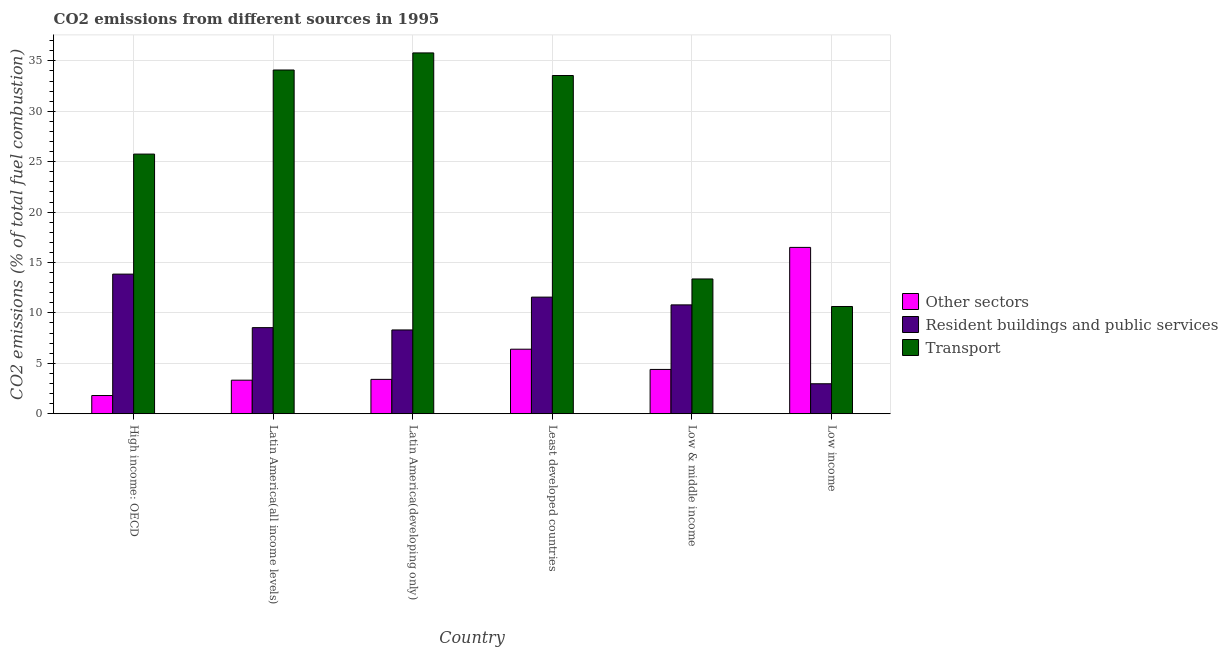What is the label of the 6th group of bars from the left?
Give a very brief answer. Low income. In how many cases, is the number of bars for a given country not equal to the number of legend labels?
Provide a short and direct response. 0. What is the percentage of co2 emissions from resident buildings and public services in High income: OECD?
Offer a terse response. 13.85. Across all countries, what is the maximum percentage of co2 emissions from resident buildings and public services?
Your response must be concise. 13.85. Across all countries, what is the minimum percentage of co2 emissions from transport?
Keep it short and to the point. 10.64. In which country was the percentage of co2 emissions from other sectors maximum?
Your response must be concise. Low income. In which country was the percentage of co2 emissions from resident buildings and public services minimum?
Ensure brevity in your answer.  Low income. What is the total percentage of co2 emissions from other sectors in the graph?
Your response must be concise. 35.84. What is the difference between the percentage of co2 emissions from transport in High income: OECD and that in Latin America(all income levels)?
Offer a very short reply. -8.34. What is the difference between the percentage of co2 emissions from transport in Low income and the percentage of co2 emissions from other sectors in Low & middle income?
Keep it short and to the point. 6.24. What is the average percentage of co2 emissions from other sectors per country?
Make the answer very short. 5.97. What is the difference between the percentage of co2 emissions from resident buildings and public services and percentage of co2 emissions from other sectors in Latin America(developing only)?
Make the answer very short. 4.9. In how many countries, is the percentage of co2 emissions from resident buildings and public services greater than 15 %?
Make the answer very short. 0. What is the ratio of the percentage of co2 emissions from transport in Latin America(all income levels) to that in Low & middle income?
Offer a very short reply. 2.55. What is the difference between the highest and the second highest percentage of co2 emissions from transport?
Make the answer very short. 1.69. What is the difference between the highest and the lowest percentage of co2 emissions from other sectors?
Provide a succinct answer. 14.69. Is the sum of the percentage of co2 emissions from transport in Latin America(developing only) and Low & middle income greater than the maximum percentage of co2 emissions from other sectors across all countries?
Your answer should be compact. Yes. What does the 1st bar from the left in Least developed countries represents?
Offer a terse response. Other sectors. What does the 3rd bar from the right in Latin America(all income levels) represents?
Your answer should be very brief. Other sectors. How many bars are there?
Keep it short and to the point. 18. Are all the bars in the graph horizontal?
Your answer should be very brief. No. What is the title of the graph?
Your answer should be very brief. CO2 emissions from different sources in 1995. Does "Consumption Tax" appear as one of the legend labels in the graph?
Your answer should be very brief. No. What is the label or title of the X-axis?
Keep it short and to the point. Country. What is the label or title of the Y-axis?
Offer a terse response. CO2 emissions (% of total fuel combustion). What is the CO2 emissions (% of total fuel combustion) of Other sectors in High income: OECD?
Your response must be concise. 1.81. What is the CO2 emissions (% of total fuel combustion) in Resident buildings and public services in High income: OECD?
Ensure brevity in your answer.  13.85. What is the CO2 emissions (% of total fuel combustion) of Transport in High income: OECD?
Give a very brief answer. 25.75. What is the CO2 emissions (% of total fuel combustion) in Other sectors in Latin America(all income levels)?
Provide a succinct answer. 3.33. What is the CO2 emissions (% of total fuel combustion) of Resident buildings and public services in Latin America(all income levels)?
Provide a short and direct response. 8.54. What is the CO2 emissions (% of total fuel combustion) in Transport in Latin America(all income levels)?
Make the answer very short. 34.09. What is the CO2 emissions (% of total fuel combustion) in Other sectors in Latin America(developing only)?
Give a very brief answer. 3.41. What is the CO2 emissions (% of total fuel combustion) of Resident buildings and public services in Latin America(developing only)?
Offer a very short reply. 8.31. What is the CO2 emissions (% of total fuel combustion) of Transport in Latin America(developing only)?
Provide a short and direct response. 35.79. What is the CO2 emissions (% of total fuel combustion) in Other sectors in Least developed countries?
Provide a short and direct response. 6.4. What is the CO2 emissions (% of total fuel combustion) in Resident buildings and public services in Least developed countries?
Provide a short and direct response. 11.57. What is the CO2 emissions (% of total fuel combustion) in Transport in Least developed countries?
Your response must be concise. 33.55. What is the CO2 emissions (% of total fuel combustion) in Other sectors in Low & middle income?
Give a very brief answer. 4.39. What is the CO2 emissions (% of total fuel combustion) in Resident buildings and public services in Low & middle income?
Give a very brief answer. 10.8. What is the CO2 emissions (% of total fuel combustion) of Transport in Low & middle income?
Make the answer very short. 13.37. What is the CO2 emissions (% of total fuel combustion) in Other sectors in Low income?
Your answer should be very brief. 16.5. What is the CO2 emissions (% of total fuel combustion) in Resident buildings and public services in Low income?
Keep it short and to the point. 2.97. What is the CO2 emissions (% of total fuel combustion) of Transport in Low income?
Offer a terse response. 10.64. Across all countries, what is the maximum CO2 emissions (% of total fuel combustion) in Other sectors?
Provide a short and direct response. 16.5. Across all countries, what is the maximum CO2 emissions (% of total fuel combustion) in Resident buildings and public services?
Make the answer very short. 13.85. Across all countries, what is the maximum CO2 emissions (% of total fuel combustion) in Transport?
Provide a succinct answer. 35.79. Across all countries, what is the minimum CO2 emissions (% of total fuel combustion) in Other sectors?
Offer a terse response. 1.81. Across all countries, what is the minimum CO2 emissions (% of total fuel combustion) of Resident buildings and public services?
Make the answer very short. 2.97. Across all countries, what is the minimum CO2 emissions (% of total fuel combustion) in Transport?
Provide a short and direct response. 10.64. What is the total CO2 emissions (% of total fuel combustion) of Other sectors in the graph?
Offer a very short reply. 35.84. What is the total CO2 emissions (% of total fuel combustion) of Resident buildings and public services in the graph?
Provide a short and direct response. 56.04. What is the total CO2 emissions (% of total fuel combustion) of Transport in the graph?
Give a very brief answer. 153.19. What is the difference between the CO2 emissions (% of total fuel combustion) in Other sectors in High income: OECD and that in Latin America(all income levels)?
Your answer should be very brief. -1.52. What is the difference between the CO2 emissions (% of total fuel combustion) of Resident buildings and public services in High income: OECD and that in Latin America(all income levels)?
Your answer should be compact. 5.31. What is the difference between the CO2 emissions (% of total fuel combustion) of Transport in High income: OECD and that in Latin America(all income levels)?
Provide a short and direct response. -8.34. What is the difference between the CO2 emissions (% of total fuel combustion) of Other sectors in High income: OECD and that in Latin America(developing only)?
Keep it short and to the point. -1.6. What is the difference between the CO2 emissions (% of total fuel combustion) in Resident buildings and public services in High income: OECD and that in Latin America(developing only)?
Offer a terse response. 5.54. What is the difference between the CO2 emissions (% of total fuel combustion) of Transport in High income: OECD and that in Latin America(developing only)?
Make the answer very short. -10.03. What is the difference between the CO2 emissions (% of total fuel combustion) in Other sectors in High income: OECD and that in Least developed countries?
Provide a short and direct response. -4.59. What is the difference between the CO2 emissions (% of total fuel combustion) in Resident buildings and public services in High income: OECD and that in Least developed countries?
Your answer should be very brief. 2.28. What is the difference between the CO2 emissions (% of total fuel combustion) of Transport in High income: OECD and that in Least developed countries?
Your response must be concise. -7.79. What is the difference between the CO2 emissions (% of total fuel combustion) of Other sectors in High income: OECD and that in Low & middle income?
Keep it short and to the point. -2.59. What is the difference between the CO2 emissions (% of total fuel combustion) in Resident buildings and public services in High income: OECD and that in Low & middle income?
Make the answer very short. 3.05. What is the difference between the CO2 emissions (% of total fuel combustion) of Transport in High income: OECD and that in Low & middle income?
Your answer should be very brief. 12.38. What is the difference between the CO2 emissions (% of total fuel combustion) in Other sectors in High income: OECD and that in Low income?
Make the answer very short. -14.69. What is the difference between the CO2 emissions (% of total fuel combustion) of Resident buildings and public services in High income: OECD and that in Low income?
Offer a very short reply. 10.87. What is the difference between the CO2 emissions (% of total fuel combustion) of Transport in High income: OECD and that in Low income?
Ensure brevity in your answer.  15.12. What is the difference between the CO2 emissions (% of total fuel combustion) of Other sectors in Latin America(all income levels) and that in Latin America(developing only)?
Your response must be concise. -0.08. What is the difference between the CO2 emissions (% of total fuel combustion) in Resident buildings and public services in Latin America(all income levels) and that in Latin America(developing only)?
Give a very brief answer. 0.23. What is the difference between the CO2 emissions (% of total fuel combustion) of Transport in Latin America(all income levels) and that in Latin America(developing only)?
Give a very brief answer. -1.69. What is the difference between the CO2 emissions (% of total fuel combustion) of Other sectors in Latin America(all income levels) and that in Least developed countries?
Make the answer very short. -3.07. What is the difference between the CO2 emissions (% of total fuel combustion) in Resident buildings and public services in Latin America(all income levels) and that in Least developed countries?
Make the answer very short. -3.03. What is the difference between the CO2 emissions (% of total fuel combustion) of Transport in Latin America(all income levels) and that in Least developed countries?
Offer a terse response. 0.55. What is the difference between the CO2 emissions (% of total fuel combustion) of Other sectors in Latin America(all income levels) and that in Low & middle income?
Provide a short and direct response. -1.07. What is the difference between the CO2 emissions (% of total fuel combustion) in Resident buildings and public services in Latin America(all income levels) and that in Low & middle income?
Offer a terse response. -2.26. What is the difference between the CO2 emissions (% of total fuel combustion) in Transport in Latin America(all income levels) and that in Low & middle income?
Your answer should be very brief. 20.72. What is the difference between the CO2 emissions (% of total fuel combustion) of Other sectors in Latin America(all income levels) and that in Low income?
Make the answer very short. -13.17. What is the difference between the CO2 emissions (% of total fuel combustion) in Resident buildings and public services in Latin America(all income levels) and that in Low income?
Your response must be concise. 5.57. What is the difference between the CO2 emissions (% of total fuel combustion) in Transport in Latin America(all income levels) and that in Low income?
Give a very brief answer. 23.46. What is the difference between the CO2 emissions (% of total fuel combustion) of Other sectors in Latin America(developing only) and that in Least developed countries?
Give a very brief answer. -2.99. What is the difference between the CO2 emissions (% of total fuel combustion) of Resident buildings and public services in Latin America(developing only) and that in Least developed countries?
Ensure brevity in your answer.  -3.26. What is the difference between the CO2 emissions (% of total fuel combustion) of Transport in Latin America(developing only) and that in Least developed countries?
Offer a very short reply. 2.24. What is the difference between the CO2 emissions (% of total fuel combustion) in Other sectors in Latin America(developing only) and that in Low & middle income?
Provide a short and direct response. -0.99. What is the difference between the CO2 emissions (% of total fuel combustion) of Resident buildings and public services in Latin America(developing only) and that in Low & middle income?
Your answer should be compact. -2.49. What is the difference between the CO2 emissions (% of total fuel combustion) in Transport in Latin America(developing only) and that in Low & middle income?
Your answer should be compact. 22.42. What is the difference between the CO2 emissions (% of total fuel combustion) in Other sectors in Latin America(developing only) and that in Low income?
Provide a short and direct response. -13.09. What is the difference between the CO2 emissions (% of total fuel combustion) of Resident buildings and public services in Latin America(developing only) and that in Low income?
Offer a terse response. 5.34. What is the difference between the CO2 emissions (% of total fuel combustion) of Transport in Latin America(developing only) and that in Low income?
Your answer should be compact. 25.15. What is the difference between the CO2 emissions (% of total fuel combustion) of Other sectors in Least developed countries and that in Low & middle income?
Give a very brief answer. 2.01. What is the difference between the CO2 emissions (% of total fuel combustion) in Resident buildings and public services in Least developed countries and that in Low & middle income?
Offer a very short reply. 0.77. What is the difference between the CO2 emissions (% of total fuel combustion) in Transport in Least developed countries and that in Low & middle income?
Give a very brief answer. 20.18. What is the difference between the CO2 emissions (% of total fuel combustion) of Other sectors in Least developed countries and that in Low income?
Keep it short and to the point. -10.1. What is the difference between the CO2 emissions (% of total fuel combustion) of Resident buildings and public services in Least developed countries and that in Low income?
Your answer should be very brief. 8.59. What is the difference between the CO2 emissions (% of total fuel combustion) in Transport in Least developed countries and that in Low income?
Ensure brevity in your answer.  22.91. What is the difference between the CO2 emissions (% of total fuel combustion) in Other sectors in Low & middle income and that in Low income?
Ensure brevity in your answer.  -12.1. What is the difference between the CO2 emissions (% of total fuel combustion) of Resident buildings and public services in Low & middle income and that in Low income?
Provide a short and direct response. 7.82. What is the difference between the CO2 emissions (% of total fuel combustion) in Transport in Low & middle income and that in Low income?
Ensure brevity in your answer.  2.73. What is the difference between the CO2 emissions (% of total fuel combustion) in Other sectors in High income: OECD and the CO2 emissions (% of total fuel combustion) in Resident buildings and public services in Latin America(all income levels)?
Offer a very short reply. -6.73. What is the difference between the CO2 emissions (% of total fuel combustion) in Other sectors in High income: OECD and the CO2 emissions (% of total fuel combustion) in Transport in Latin America(all income levels)?
Ensure brevity in your answer.  -32.29. What is the difference between the CO2 emissions (% of total fuel combustion) in Resident buildings and public services in High income: OECD and the CO2 emissions (% of total fuel combustion) in Transport in Latin America(all income levels)?
Offer a very short reply. -20.25. What is the difference between the CO2 emissions (% of total fuel combustion) in Other sectors in High income: OECD and the CO2 emissions (% of total fuel combustion) in Resident buildings and public services in Latin America(developing only)?
Ensure brevity in your answer.  -6.5. What is the difference between the CO2 emissions (% of total fuel combustion) in Other sectors in High income: OECD and the CO2 emissions (% of total fuel combustion) in Transport in Latin America(developing only)?
Your response must be concise. -33.98. What is the difference between the CO2 emissions (% of total fuel combustion) in Resident buildings and public services in High income: OECD and the CO2 emissions (% of total fuel combustion) in Transport in Latin America(developing only)?
Offer a very short reply. -21.94. What is the difference between the CO2 emissions (% of total fuel combustion) in Other sectors in High income: OECD and the CO2 emissions (% of total fuel combustion) in Resident buildings and public services in Least developed countries?
Provide a short and direct response. -9.76. What is the difference between the CO2 emissions (% of total fuel combustion) of Other sectors in High income: OECD and the CO2 emissions (% of total fuel combustion) of Transport in Least developed countries?
Give a very brief answer. -31.74. What is the difference between the CO2 emissions (% of total fuel combustion) in Resident buildings and public services in High income: OECD and the CO2 emissions (% of total fuel combustion) in Transport in Least developed countries?
Keep it short and to the point. -19.7. What is the difference between the CO2 emissions (% of total fuel combustion) in Other sectors in High income: OECD and the CO2 emissions (% of total fuel combustion) in Resident buildings and public services in Low & middle income?
Offer a very short reply. -8.99. What is the difference between the CO2 emissions (% of total fuel combustion) of Other sectors in High income: OECD and the CO2 emissions (% of total fuel combustion) of Transport in Low & middle income?
Offer a terse response. -11.56. What is the difference between the CO2 emissions (% of total fuel combustion) of Resident buildings and public services in High income: OECD and the CO2 emissions (% of total fuel combustion) of Transport in Low & middle income?
Make the answer very short. 0.48. What is the difference between the CO2 emissions (% of total fuel combustion) of Other sectors in High income: OECD and the CO2 emissions (% of total fuel combustion) of Resident buildings and public services in Low income?
Your answer should be very brief. -1.17. What is the difference between the CO2 emissions (% of total fuel combustion) of Other sectors in High income: OECD and the CO2 emissions (% of total fuel combustion) of Transport in Low income?
Make the answer very short. -8.83. What is the difference between the CO2 emissions (% of total fuel combustion) in Resident buildings and public services in High income: OECD and the CO2 emissions (% of total fuel combustion) in Transport in Low income?
Make the answer very short. 3.21. What is the difference between the CO2 emissions (% of total fuel combustion) in Other sectors in Latin America(all income levels) and the CO2 emissions (% of total fuel combustion) in Resident buildings and public services in Latin America(developing only)?
Provide a succinct answer. -4.98. What is the difference between the CO2 emissions (% of total fuel combustion) in Other sectors in Latin America(all income levels) and the CO2 emissions (% of total fuel combustion) in Transport in Latin America(developing only)?
Offer a terse response. -32.46. What is the difference between the CO2 emissions (% of total fuel combustion) in Resident buildings and public services in Latin America(all income levels) and the CO2 emissions (% of total fuel combustion) in Transport in Latin America(developing only)?
Keep it short and to the point. -27.25. What is the difference between the CO2 emissions (% of total fuel combustion) in Other sectors in Latin America(all income levels) and the CO2 emissions (% of total fuel combustion) in Resident buildings and public services in Least developed countries?
Provide a succinct answer. -8.24. What is the difference between the CO2 emissions (% of total fuel combustion) of Other sectors in Latin America(all income levels) and the CO2 emissions (% of total fuel combustion) of Transport in Least developed countries?
Provide a short and direct response. -30.22. What is the difference between the CO2 emissions (% of total fuel combustion) in Resident buildings and public services in Latin America(all income levels) and the CO2 emissions (% of total fuel combustion) in Transport in Least developed countries?
Offer a terse response. -25.01. What is the difference between the CO2 emissions (% of total fuel combustion) in Other sectors in Latin America(all income levels) and the CO2 emissions (% of total fuel combustion) in Resident buildings and public services in Low & middle income?
Provide a short and direct response. -7.47. What is the difference between the CO2 emissions (% of total fuel combustion) of Other sectors in Latin America(all income levels) and the CO2 emissions (% of total fuel combustion) of Transport in Low & middle income?
Your answer should be very brief. -10.04. What is the difference between the CO2 emissions (% of total fuel combustion) in Resident buildings and public services in Latin America(all income levels) and the CO2 emissions (% of total fuel combustion) in Transport in Low & middle income?
Offer a terse response. -4.83. What is the difference between the CO2 emissions (% of total fuel combustion) in Other sectors in Latin America(all income levels) and the CO2 emissions (% of total fuel combustion) in Resident buildings and public services in Low income?
Keep it short and to the point. 0.35. What is the difference between the CO2 emissions (% of total fuel combustion) of Other sectors in Latin America(all income levels) and the CO2 emissions (% of total fuel combustion) of Transport in Low income?
Make the answer very short. -7.31. What is the difference between the CO2 emissions (% of total fuel combustion) of Resident buildings and public services in Latin America(all income levels) and the CO2 emissions (% of total fuel combustion) of Transport in Low income?
Your answer should be very brief. -2.1. What is the difference between the CO2 emissions (% of total fuel combustion) of Other sectors in Latin America(developing only) and the CO2 emissions (% of total fuel combustion) of Resident buildings and public services in Least developed countries?
Offer a terse response. -8.16. What is the difference between the CO2 emissions (% of total fuel combustion) in Other sectors in Latin America(developing only) and the CO2 emissions (% of total fuel combustion) in Transport in Least developed countries?
Keep it short and to the point. -30.14. What is the difference between the CO2 emissions (% of total fuel combustion) of Resident buildings and public services in Latin America(developing only) and the CO2 emissions (% of total fuel combustion) of Transport in Least developed countries?
Give a very brief answer. -25.24. What is the difference between the CO2 emissions (% of total fuel combustion) in Other sectors in Latin America(developing only) and the CO2 emissions (% of total fuel combustion) in Resident buildings and public services in Low & middle income?
Ensure brevity in your answer.  -7.39. What is the difference between the CO2 emissions (% of total fuel combustion) in Other sectors in Latin America(developing only) and the CO2 emissions (% of total fuel combustion) in Transport in Low & middle income?
Your answer should be very brief. -9.96. What is the difference between the CO2 emissions (% of total fuel combustion) in Resident buildings and public services in Latin America(developing only) and the CO2 emissions (% of total fuel combustion) in Transport in Low & middle income?
Offer a terse response. -5.06. What is the difference between the CO2 emissions (% of total fuel combustion) in Other sectors in Latin America(developing only) and the CO2 emissions (% of total fuel combustion) in Resident buildings and public services in Low income?
Provide a succinct answer. 0.44. What is the difference between the CO2 emissions (% of total fuel combustion) of Other sectors in Latin America(developing only) and the CO2 emissions (% of total fuel combustion) of Transport in Low income?
Ensure brevity in your answer.  -7.23. What is the difference between the CO2 emissions (% of total fuel combustion) in Resident buildings and public services in Latin America(developing only) and the CO2 emissions (% of total fuel combustion) in Transport in Low income?
Offer a terse response. -2.33. What is the difference between the CO2 emissions (% of total fuel combustion) of Other sectors in Least developed countries and the CO2 emissions (% of total fuel combustion) of Resident buildings and public services in Low & middle income?
Make the answer very short. -4.4. What is the difference between the CO2 emissions (% of total fuel combustion) of Other sectors in Least developed countries and the CO2 emissions (% of total fuel combustion) of Transport in Low & middle income?
Ensure brevity in your answer.  -6.97. What is the difference between the CO2 emissions (% of total fuel combustion) of Resident buildings and public services in Least developed countries and the CO2 emissions (% of total fuel combustion) of Transport in Low & middle income?
Offer a terse response. -1.8. What is the difference between the CO2 emissions (% of total fuel combustion) of Other sectors in Least developed countries and the CO2 emissions (% of total fuel combustion) of Resident buildings and public services in Low income?
Make the answer very short. 3.43. What is the difference between the CO2 emissions (% of total fuel combustion) in Other sectors in Least developed countries and the CO2 emissions (% of total fuel combustion) in Transport in Low income?
Keep it short and to the point. -4.24. What is the difference between the CO2 emissions (% of total fuel combustion) in Resident buildings and public services in Least developed countries and the CO2 emissions (% of total fuel combustion) in Transport in Low income?
Ensure brevity in your answer.  0.93. What is the difference between the CO2 emissions (% of total fuel combustion) of Other sectors in Low & middle income and the CO2 emissions (% of total fuel combustion) of Resident buildings and public services in Low income?
Your answer should be compact. 1.42. What is the difference between the CO2 emissions (% of total fuel combustion) of Other sectors in Low & middle income and the CO2 emissions (% of total fuel combustion) of Transport in Low income?
Offer a very short reply. -6.24. What is the difference between the CO2 emissions (% of total fuel combustion) in Resident buildings and public services in Low & middle income and the CO2 emissions (% of total fuel combustion) in Transport in Low income?
Provide a short and direct response. 0.16. What is the average CO2 emissions (% of total fuel combustion) of Other sectors per country?
Provide a short and direct response. 5.97. What is the average CO2 emissions (% of total fuel combustion) in Resident buildings and public services per country?
Your answer should be compact. 9.34. What is the average CO2 emissions (% of total fuel combustion) of Transport per country?
Offer a very short reply. 25.53. What is the difference between the CO2 emissions (% of total fuel combustion) of Other sectors and CO2 emissions (% of total fuel combustion) of Resident buildings and public services in High income: OECD?
Give a very brief answer. -12.04. What is the difference between the CO2 emissions (% of total fuel combustion) of Other sectors and CO2 emissions (% of total fuel combustion) of Transport in High income: OECD?
Give a very brief answer. -23.95. What is the difference between the CO2 emissions (% of total fuel combustion) in Resident buildings and public services and CO2 emissions (% of total fuel combustion) in Transport in High income: OECD?
Give a very brief answer. -11.9. What is the difference between the CO2 emissions (% of total fuel combustion) of Other sectors and CO2 emissions (% of total fuel combustion) of Resident buildings and public services in Latin America(all income levels)?
Offer a very short reply. -5.21. What is the difference between the CO2 emissions (% of total fuel combustion) of Other sectors and CO2 emissions (% of total fuel combustion) of Transport in Latin America(all income levels)?
Keep it short and to the point. -30.76. What is the difference between the CO2 emissions (% of total fuel combustion) of Resident buildings and public services and CO2 emissions (% of total fuel combustion) of Transport in Latin America(all income levels)?
Make the answer very short. -25.55. What is the difference between the CO2 emissions (% of total fuel combustion) of Other sectors and CO2 emissions (% of total fuel combustion) of Resident buildings and public services in Latin America(developing only)?
Your response must be concise. -4.9. What is the difference between the CO2 emissions (% of total fuel combustion) in Other sectors and CO2 emissions (% of total fuel combustion) in Transport in Latin America(developing only)?
Provide a short and direct response. -32.38. What is the difference between the CO2 emissions (% of total fuel combustion) of Resident buildings and public services and CO2 emissions (% of total fuel combustion) of Transport in Latin America(developing only)?
Give a very brief answer. -27.48. What is the difference between the CO2 emissions (% of total fuel combustion) of Other sectors and CO2 emissions (% of total fuel combustion) of Resident buildings and public services in Least developed countries?
Keep it short and to the point. -5.17. What is the difference between the CO2 emissions (% of total fuel combustion) of Other sectors and CO2 emissions (% of total fuel combustion) of Transport in Least developed countries?
Ensure brevity in your answer.  -27.15. What is the difference between the CO2 emissions (% of total fuel combustion) of Resident buildings and public services and CO2 emissions (% of total fuel combustion) of Transport in Least developed countries?
Keep it short and to the point. -21.98. What is the difference between the CO2 emissions (% of total fuel combustion) in Other sectors and CO2 emissions (% of total fuel combustion) in Resident buildings and public services in Low & middle income?
Offer a terse response. -6.4. What is the difference between the CO2 emissions (% of total fuel combustion) in Other sectors and CO2 emissions (% of total fuel combustion) in Transport in Low & middle income?
Ensure brevity in your answer.  -8.97. What is the difference between the CO2 emissions (% of total fuel combustion) in Resident buildings and public services and CO2 emissions (% of total fuel combustion) in Transport in Low & middle income?
Your answer should be very brief. -2.57. What is the difference between the CO2 emissions (% of total fuel combustion) of Other sectors and CO2 emissions (% of total fuel combustion) of Resident buildings and public services in Low income?
Offer a terse response. 13.52. What is the difference between the CO2 emissions (% of total fuel combustion) in Other sectors and CO2 emissions (% of total fuel combustion) in Transport in Low income?
Offer a terse response. 5.86. What is the difference between the CO2 emissions (% of total fuel combustion) in Resident buildings and public services and CO2 emissions (% of total fuel combustion) in Transport in Low income?
Your answer should be compact. -7.66. What is the ratio of the CO2 emissions (% of total fuel combustion) in Other sectors in High income: OECD to that in Latin America(all income levels)?
Give a very brief answer. 0.54. What is the ratio of the CO2 emissions (% of total fuel combustion) in Resident buildings and public services in High income: OECD to that in Latin America(all income levels)?
Your response must be concise. 1.62. What is the ratio of the CO2 emissions (% of total fuel combustion) of Transport in High income: OECD to that in Latin America(all income levels)?
Keep it short and to the point. 0.76. What is the ratio of the CO2 emissions (% of total fuel combustion) of Other sectors in High income: OECD to that in Latin America(developing only)?
Offer a very short reply. 0.53. What is the ratio of the CO2 emissions (% of total fuel combustion) in Resident buildings and public services in High income: OECD to that in Latin America(developing only)?
Provide a short and direct response. 1.67. What is the ratio of the CO2 emissions (% of total fuel combustion) of Transport in High income: OECD to that in Latin America(developing only)?
Provide a short and direct response. 0.72. What is the ratio of the CO2 emissions (% of total fuel combustion) of Other sectors in High income: OECD to that in Least developed countries?
Keep it short and to the point. 0.28. What is the ratio of the CO2 emissions (% of total fuel combustion) in Resident buildings and public services in High income: OECD to that in Least developed countries?
Provide a succinct answer. 1.2. What is the ratio of the CO2 emissions (% of total fuel combustion) in Transport in High income: OECD to that in Least developed countries?
Offer a very short reply. 0.77. What is the ratio of the CO2 emissions (% of total fuel combustion) of Other sectors in High income: OECD to that in Low & middle income?
Provide a short and direct response. 0.41. What is the ratio of the CO2 emissions (% of total fuel combustion) in Resident buildings and public services in High income: OECD to that in Low & middle income?
Offer a very short reply. 1.28. What is the ratio of the CO2 emissions (% of total fuel combustion) of Transport in High income: OECD to that in Low & middle income?
Your answer should be very brief. 1.93. What is the ratio of the CO2 emissions (% of total fuel combustion) of Other sectors in High income: OECD to that in Low income?
Your response must be concise. 0.11. What is the ratio of the CO2 emissions (% of total fuel combustion) of Resident buildings and public services in High income: OECD to that in Low income?
Keep it short and to the point. 4.66. What is the ratio of the CO2 emissions (% of total fuel combustion) in Transport in High income: OECD to that in Low income?
Offer a very short reply. 2.42. What is the ratio of the CO2 emissions (% of total fuel combustion) in Other sectors in Latin America(all income levels) to that in Latin America(developing only)?
Provide a succinct answer. 0.98. What is the ratio of the CO2 emissions (% of total fuel combustion) of Resident buildings and public services in Latin America(all income levels) to that in Latin America(developing only)?
Your answer should be very brief. 1.03. What is the ratio of the CO2 emissions (% of total fuel combustion) of Transport in Latin America(all income levels) to that in Latin America(developing only)?
Provide a short and direct response. 0.95. What is the ratio of the CO2 emissions (% of total fuel combustion) of Other sectors in Latin America(all income levels) to that in Least developed countries?
Give a very brief answer. 0.52. What is the ratio of the CO2 emissions (% of total fuel combustion) of Resident buildings and public services in Latin America(all income levels) to that in Least developed countries?
Give a very brief answer. 0.74. What is the ratio of the CO2 emissions (% of total fuel combustion) in Transport in Latin America(all income levels) to that in Least developed countries?
Provide a succinct answer. 1.02. What is the ratio of the CO2 emissions (% of total fuel combustion) in Other sectors in Latin America(all income levels) to that in Low & middle income?
Your answer should be very brief. 0.76. What is the ratio of the CO2 emissions (% of total fuel combustion) of Resident buildings and public services in Latin America(all income levels) to that in Low & middle income?
Your answer should be compact. 0.79. What is the ratio of the CO2 emissions (% of total fuel combustion) in Transport in Latin America(all income levels) to that in Low & middle income?
Your response must be concise. 2.55. What is the ratio of the CO2 emissions (% of total fuel combustion) in Other sectors in Latin America(all income levels) to that in Low income?
Provide a succinct answer. 0.2. What is the ratio of the CO2 emissions (% of total fuel combustion) of Resident buildings and public services in Latin America(all income levels) to that in Low income?
Offer a terse response. 2.87. What is the ratio of the CO2 emissions (% of total fuel combustion) in Transport in Latin America(all income levels) to that in Low income?
Keep it short and to the point. 3.21. What is the ratio of the CO2 emissions (% of total fuel combustion) of Other sectors in Latin America(developing only) to that in Least developed countries?
Provide a short and direct response. 0.53. What is the ratio of the CO2 emissions (% of total fuel combustion) in Resident buildings and public services in Latin America(developing only) to that in Least developed countries?
Give a very brief answer. 0.72. What is the ratio of the CO2 emissions (% of total fuel combustion) in Transport in Latin America(developing only) to that in Least developed countries?
Offer a terse response. 1.07. What is the ratio of the CO2 emissions (% of total fuel combustion) in Other sectors in Latin America(developing only) to that in Low & middle income?
Keep it short and to the point. 0.78. What is the ratio of the CO2 emissions (% of total fuel combustion) of Resident buildings and public services in Latin America(developing only) to that in Low & middle income?
Offer a very short reply. 0.77. What is the ratio of the CO2 emissions (% of total fuel combustion) in Transport in Latin America(developing only) to that in Low & middle income?
Offer a terse response. 2.68. What is the ratio of the CO2 emissions (% of total fuel combustion) in Other sectors in Latin America(developing only) to that in Low income?
Your answer should be very brief. 0.21. What is the ratio of the CO2 emissions (% of total fuel combustion) in Resident buildings and public services in Latin America(developing only) to that in Low income?
Make the answer very short. 2.79. What is the ratio of the CO2 emissions (% of total fuel combustion) of Transport in Latin America(developing only) to that in Low income?
Provide a short and direct response. 3.36. What is the ratio of the CO2 emissions (% of total fuel combustion) in Other sectors in Least developed countries to that in Low & middle income?
Ensure brevity in your answer.  1.46. What is the ratio of the CO2 emissions (% of total fuel combustion) of Resident buildings and public services in Least developed countries to that in Low & middle income?
Your answer should be compact. 1.07. What is the ratio of the CO2 emissions (% of total fuel combustion) in Transport in Least developed countries to that in Low & middle income?
Make the answer very short. 2.51. What is the ratio of the CO2 emissions (% of total fuel combustion) in Other sectors in Least developed countries to that in Low income?
Provide a short and direct response. 0.39. What is the ratio of the CO2 emissions (% of total fuel combustion) in Resident buildings and public services in Least developed countries to that in Low income?
Ensure brevity in your answer.  3.89. What is the ratio of the CO2 emissions (% of total fuel combustion) of Transport in Least developed countries to that in Low income?
Provide a short and direct response. 3.15. What is the ratio of the CO2 emissions (% of total fuel combustion) of Other sectors in Low & middle income to that in Low income?
Give a very brief answer. 0.27. What is the ratio of the CO2 emissions (% of total fuel combustion) in Resident buildings and public services in Low & middle income to that in Low income?
Your answer should be compact. 3.63. What is the ratio of the CO2 emissions (% of total fuel combustion) of Transport in Low & middle income to that in Low income?
Provide a short and direct response. 1.26. What is the difference between the highest and the second highest CO2 emissions (% of total fuel combustion) in Other sectors?
Give a very brief answer. 10.1. What is the difference between the highest and the second highest CO2 emissions (% of total fuel combustion) of Resident buildings and public services?
Offer a terse response. 2.28. What is the difference between the highest and the second highest CO2 emissions (% of total fuel combustion) of Transport?
Provide a short and direct response. 1.69. What is the difference between the highest and the lowest CO2 emissions (% of total fuel combustion) of Other sectors?
Make the answer very short. 14.69. What is the difference between the highest and the lowest CO2 emissions (% of total fuel combustion) of Resident buildings and public services?
Offer a very short reply. 10.87. What is the difference between the highest and the lowest CO2 emissions (% of total fuel combustion) in Transport?
Make the answer very short. 25.15. 